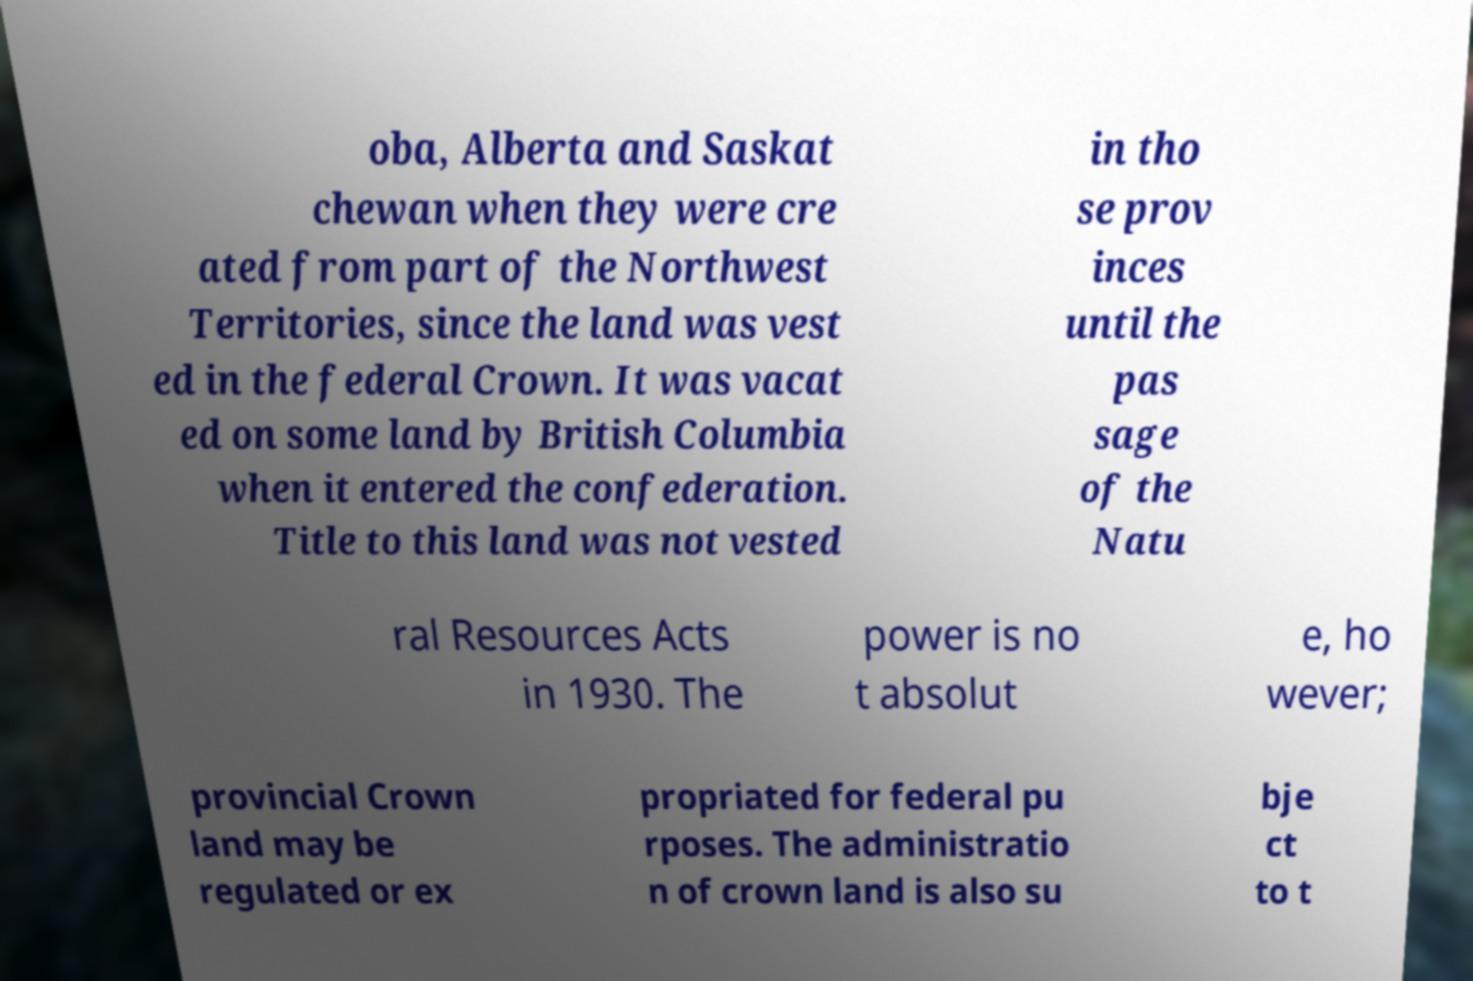What messages or text are displayed in this image? I need them in a readable, typed format. oba, Alberta and Saskat chewan when they were cre ated from part of the Northwest Territories, since the land was vest ed in the federal Crown. It was vacat ed on some land by British Columbia when it entered the confederation. Title to this land was not vested in tho se prov inces until the pas sage of the Natu ral Resources Acts in 1930. The power is no t absolut e, ho wever; provincial Crown land may be regulated or ex propriated for federal pu rposes. The administratio n of crown land is also su bje ct to t 